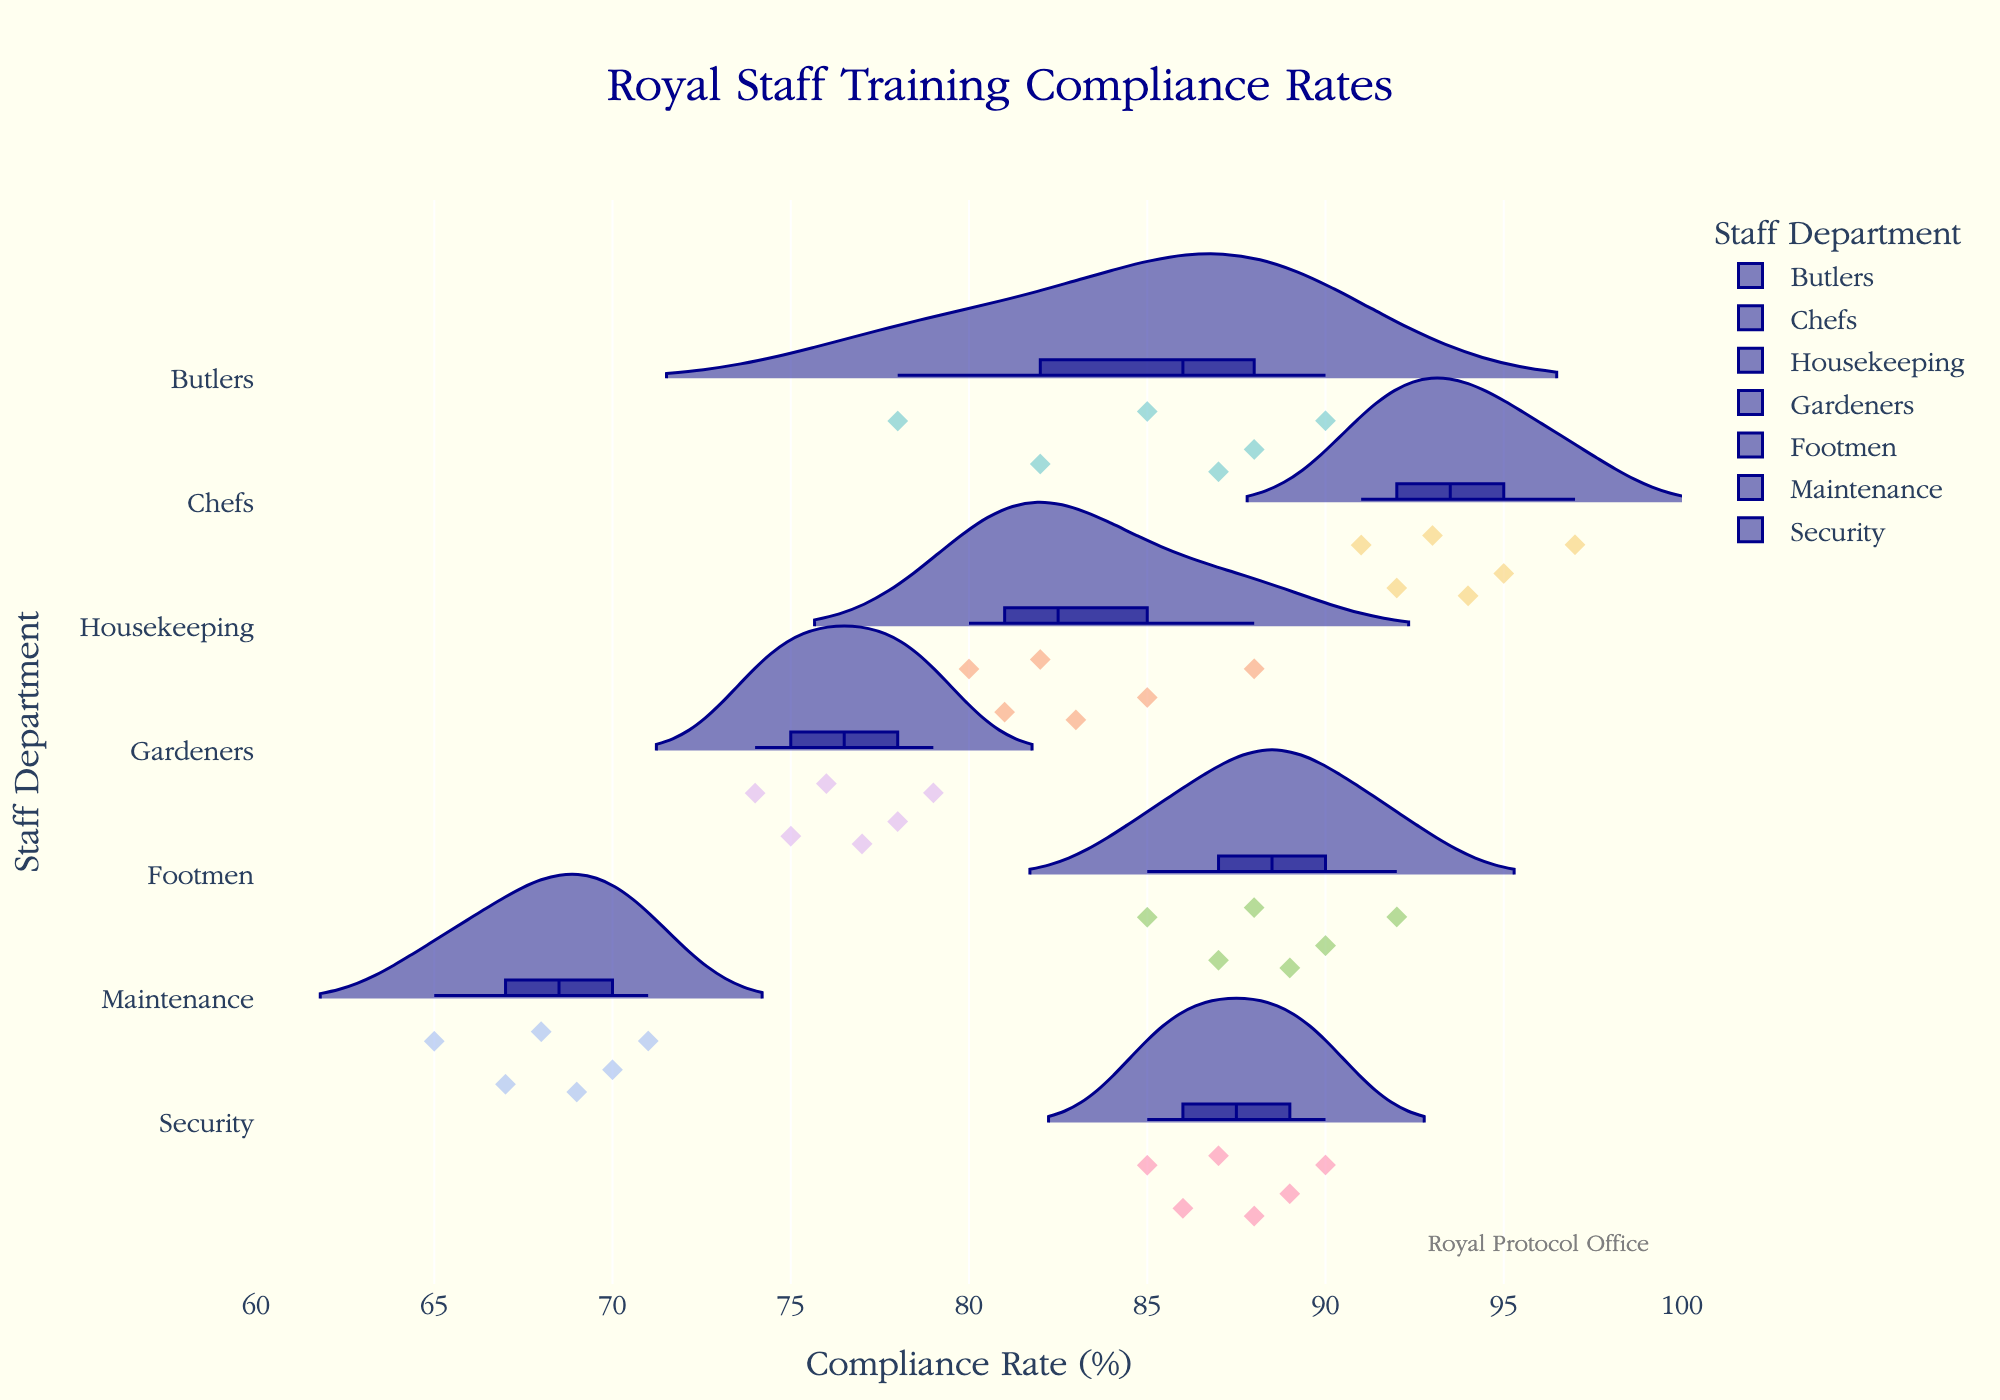What's the title of the chart? The title is positioned at the top of the chart shown in large font size.
Answer: Royal Staff Training Compliance Rates Which department shows the highest range of training compliance rates? By observing the width of the violin plots, we see the spread of data points; the Maintenance department shows the highest range as it spans from 65% to 71%.
Answer: Maintenance What is the median training compliance rate for Chefs? The violin plot for Chefs includes a box plot, where the middle line represents the median.
Answer: 94% Compare the maximum compliance rates between Security and Butlers. Which one is higher? The violin plot for Security shows a maximum rate of 90%, whereas for Butlers it's slightly higher at 90%. Both values are observed at the top points of their respective plots.
Answer: Both are 90% How many departments have training compliance rates that extend below 80%? By observing the minimum data points on each violin plot: Gardeners (74%), Maintenance (65%), and Housekeeping (80%) have one or more data points below 80%.
Answer: 3 Which department has the most consistent training compliance rates? Consistency can be inferred by the narrowest spread of the violin plot. The Chefs department, with rates close together from 91% to 97%, shows the most consistent rates.
Answer: Chefs What is the interquartile range of the training compliance rate for Housekeeping? The interquartile range (IQR) is the difference between the 75th percentile and 25th percentile within the box plot section of Housekeeping's violin plot. From the plot, the upper quartile is 85% and the lower quartile is 81%, giving an IQR of 85% - 81%.
Answer: 4% Which department appears to have the lowest overall training compliance rates? By examining the lowest points across all violin plots, the Maintenance department has the lowest rates, ranging from 65% to 71%.
Answer: Maintenance What is the average of the maximum compliance rates across all departments? To determine the average maximum compliance rates, identify the maximum rates in each department and then compute their average. The identified maximums are as follows: Butlers (90%), Chefs (97%), Housekeeping (88%), Gardeners (79%), Footmen (92%), Maintenance (71%), and Security (90%). The average of these is (90 + 97 + 88 + 79 + 92 + 71 + 90) / 7 = 86.71%.
Answer: 86.71% Is there any department with training compliance rates that do not fall below 85%? From the violin plots: Footmen (85-92%), Security (85-90%) and Chefs (91-97%) exhibit ranges exclusively above the threshold of 85%.
Answer: Yes, Footmen, Security, and Chefs 